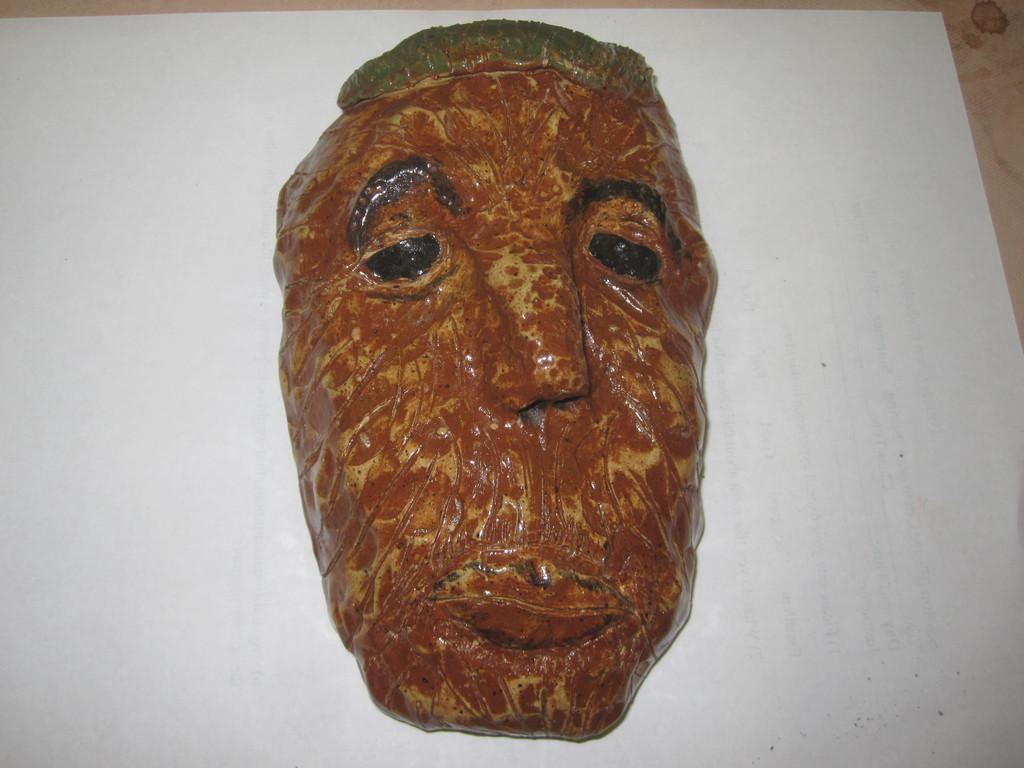What is the main subject of the image? There is a sculpture in the image. Can you describe the sculpture? The sculpture is of a person's face. What is the background or surface on which the sculpture is placed? The sculpture is on a white surface. What type of smoke can be seen coming from the sculpture's mouth in the image? There is no smoke present in the image; it features a sculpture of a person's face on a white surface. What material is the copper apparatus made of in the image? There is no copper apparatus present in the image. 